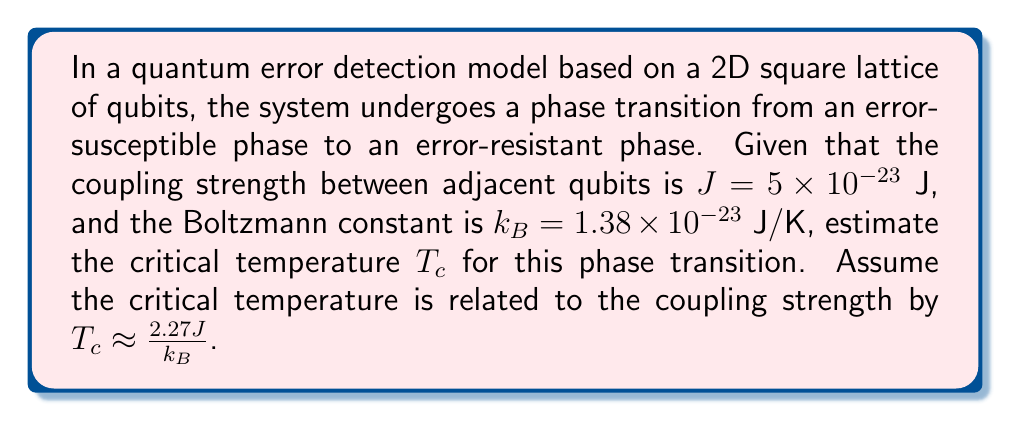Solve this math problem. To estimate the critical temperature $T_c$ for the phase transition in this quantum error detection model, we can follow these steps:

1. Identify the given information:
   - Coupling strength: $J = 5 \times 10^{-23}$ J
   - Boltzmann constant: $k_B = 1.38 \times 10^{-23}$ J/K
   - Relation between $T_c$ and $J$: $T_c \approx \frac{2.27J}{k_B}$

2. Substitute the values into the equation:
   $$T_c \approx \frac{2.27J}{k_B}$$
   $$T_c \approx \frac{2.27 \times (5 \times 10^{-23} \text{ J})}{1.38 \times 10^{-23} \text{ J/K}}$$

3. Simplify the calculation:
   $$T_c \approx \frac{11.35 \times 10^{-23}}{1.38 \times 10^{-23}} \text{ K}$$
   $$T_c \approx 8.22 \text{ K}$$

4. Round the result to two decimal places for a reasonable estimate:
   $$T_c \approx 8.22 \text{ K}$$
Answer: $8.22 \text{ K}$ 